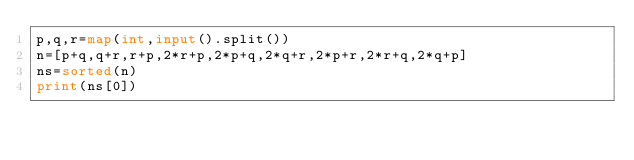Convert code to text. <code><loc_0><loc_0><loc_500><loc_500><_Python_>p,q,r=map(int,input().split())
n=[p+q,q+r,r+p,2*r+p,2*p+q,2*q+r,2*p+r,2*r+q,2*q+p]
ns=sorted(n)
print(ns[0])</code> 